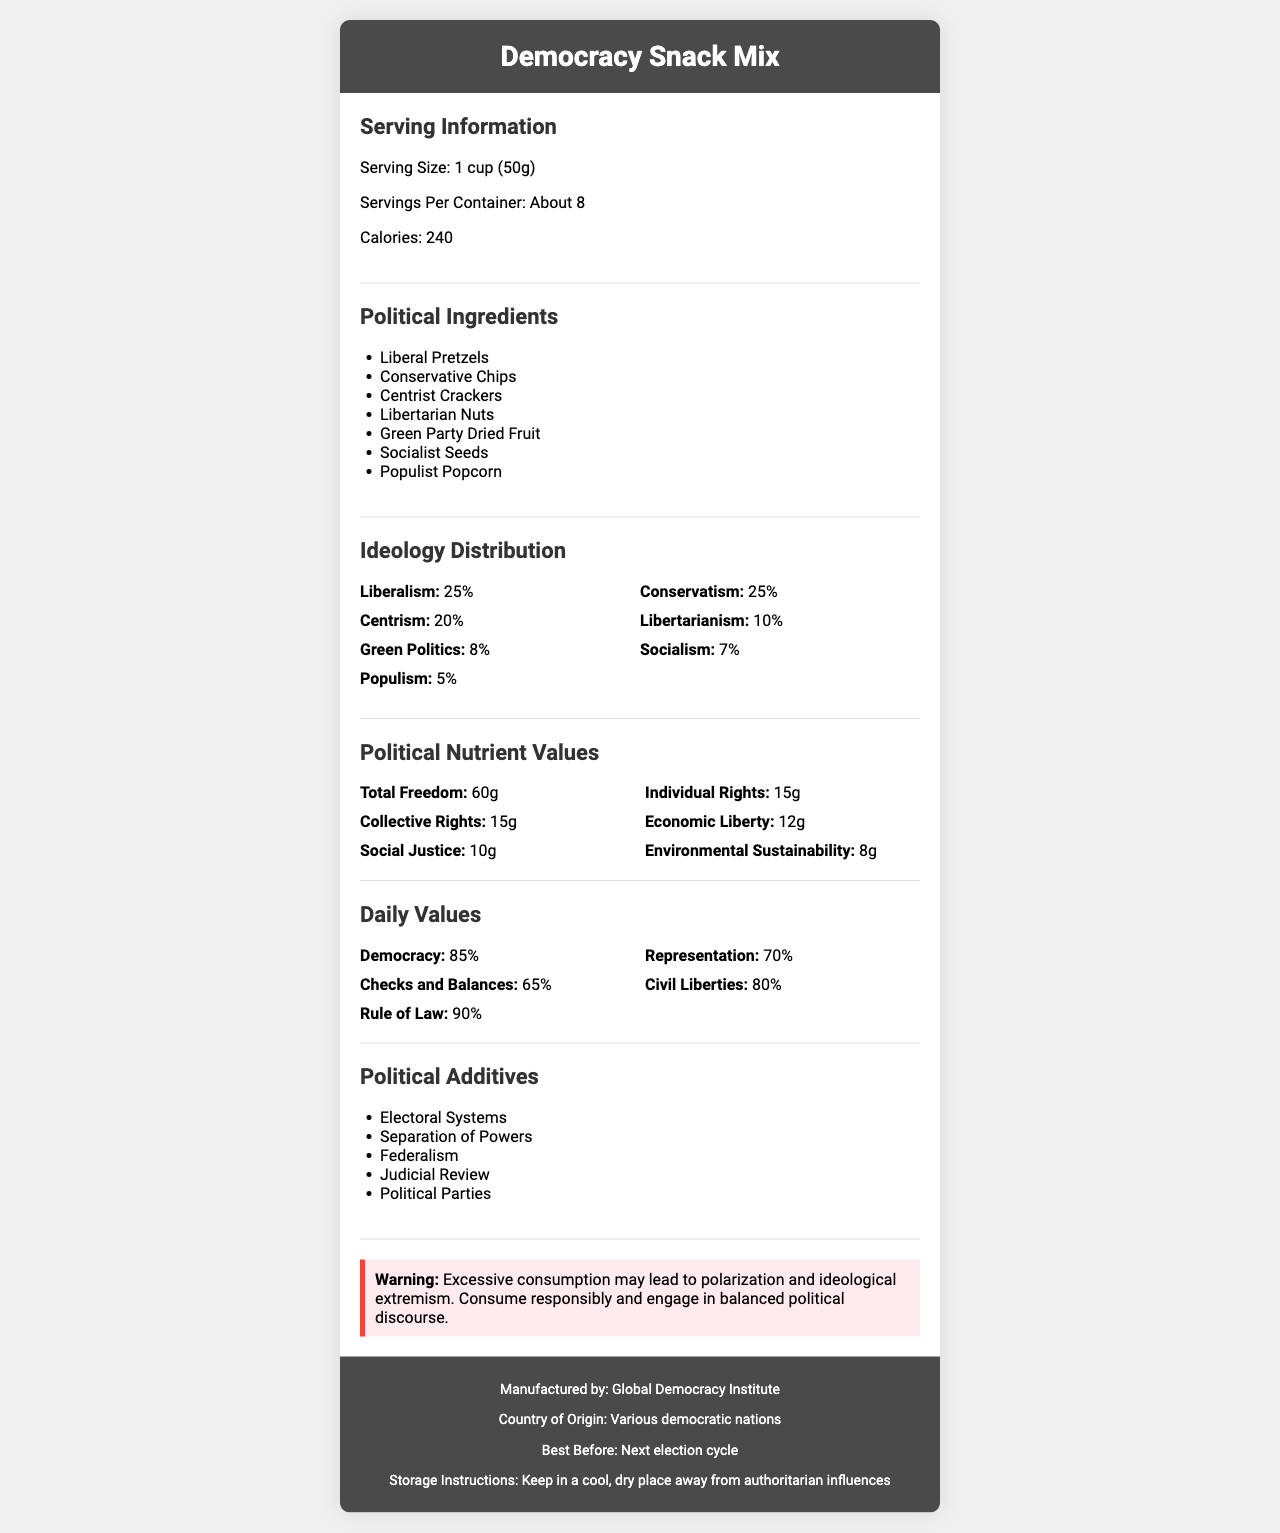Who manufactures the Democracy Snack Mix? The footer of the document lists "Manufactured by: Global Democracy Institute."
Answer: Global Democracy Institute What is the serving size of the Democracy Snack Mix? The serving information section specifies the serving size as "1 cup (50g)."
Answer: 1 cup (50g) What percentage of the mix represents Liberalism according to the ideology distribution? The Ideology Distribution section indicates that Liberalism accounts for 25% of the mix.
Answer: 25% Name two political additives found in the Democracy Snack Mix. These are listed in the Political Additives section.
Answer: Electoral Systems and Separation of Powers What is the best before date for the Democracy Snack Mix? The footer states "Best Before: Next election cycle."
Answer: Next election cycle How much Total Freedom does one serving of the Democracy Snack Mix contain? The Political Nutrient Values section lists "Total Freedom: 60g."
Answer: 60g What is the calorie content per serving? The Serving Information section mentions that there are 240 calories per serving.
Answer: 240 Calories What is the percentage of Democracy in the daily values? The Daily Values section lists "Democracy: 85%."
Answer: 85% Which category has the lowest percentage in the ideology distribution? A. Conservatism B. Green Politics C. Socialism D. Populism The Ideology Distribution section lists Populism at 5%, which is the lowest percentage.
Answer: D. Populism What is the storage instruction for the Democracy Snack Mix? A. Store in the refrigerator B. Keep in a cool, dry place away from sunlight C. Keep in a cool, dry place away from authoritarian influences D. Store at room temperature The footer states "Storage Instructions: Keep in a cool, dry place away from authoritarian influences."
Answer: C. Keep in a cool, dry place away from authoritarian influences Does the democracy snack mix contain any socialist ingredients? The Political Ingredients section includes "Socialist Seeds."
Answer: Yes Summarize the information provided on the Democracy Snack Mix's Nutrition Facts Label. This summary encompasses all sections of the document, including serving information, ingredient list, ideology breakdown, nutrient values, daily values, additives, storage instructions, manufacturing details, and a warning.
Answer: The Democracy Snack Mix has a specified serving size of 1 cup (50g) with about 8 servings per container. It provides 240 calories per serving. The mix includes several political ingredients like Liberal Pretzels and Conservative Chips, with an ideology distribution dominated by Liberalism and Conservatism at 25% each. Nutritionally, it includes values like Total Freedom (60g) and Social Justice (10g). Daily values for components like Democracy (85%) and Civil Liberties (80%) emphasize the political theme. The label also includes miscellaneous additives such as Electoral Systems and warns against excessive consumption leading to polarization. It is manufactured by the Global Democracy Institute and should be stored away from authoritarian influences. How many grams of Environmental Sustainability does the mix contain? The Political Nutrient Values section lists "Environmental Sustainability: 8g."
Answer: 8g What might happen if you consume the mix excessively? The warning section clearly states that "Excessive consumption may lead to polarization and ideological extremism."
Answer: Polarization and ideological extremism Where is the Democracy Snack Mix manufactured? The footer states "Country of Origin: Various democratic nations."
Answer: Various democratic nations What is the main political risk associated with consuming this snack mix? The document's warning section states that excessive consumption may lead to polarization and ideological extremism.
Answer: Polarization and ideological extremism Who is the target audience for this product based on the provided information? The document does not provide specific information about the target audience for this product.
Answer: Cannot be determined 